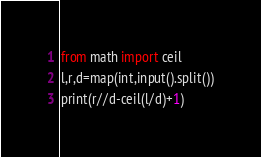<code> <loc_0><loc_0><loc_500><loc_500><_Python_>from math import ceil
l,r,d=map(int,input().split())
print(r//d-ceil(l/d)+1)
</code> 